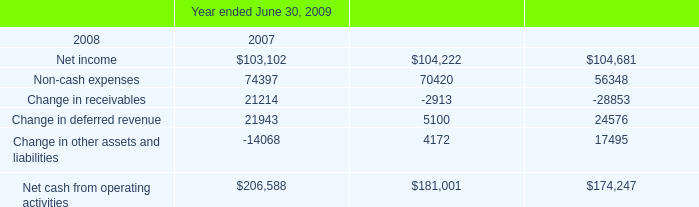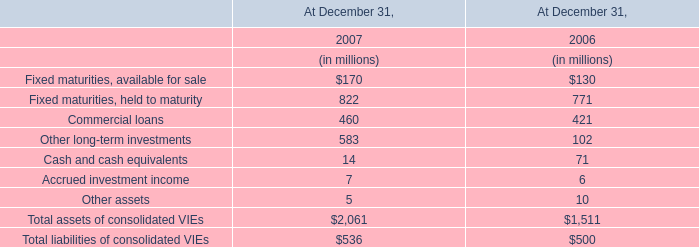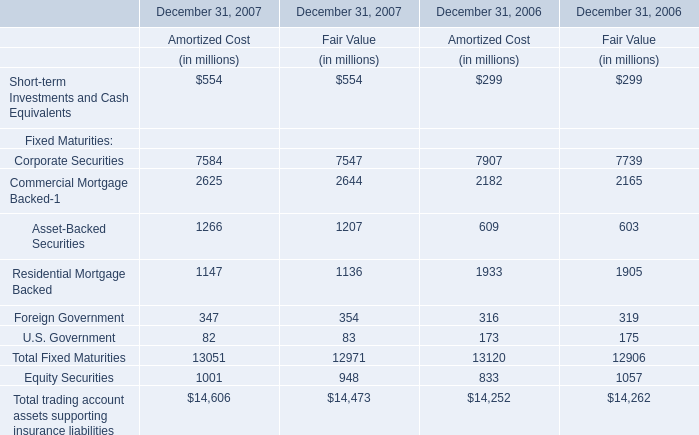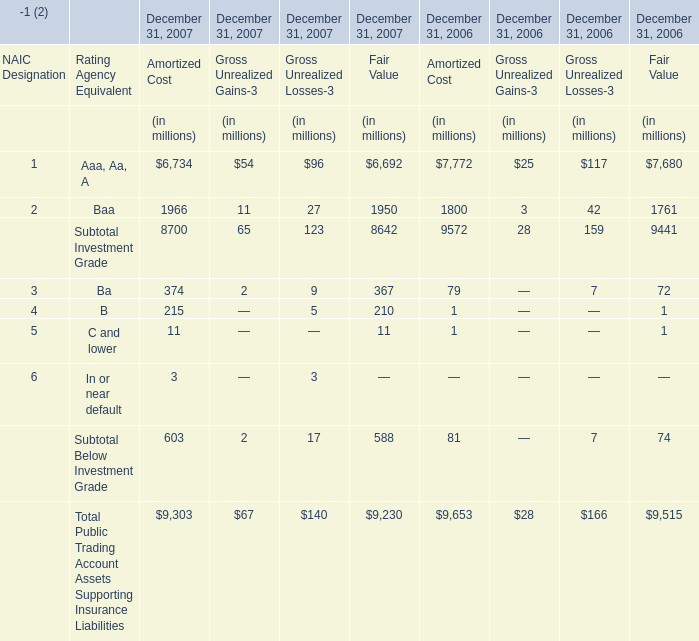Does the average value of Total Fixed Maturities in 2007 for fair value greater than that in 2006 for fair value ? 
Computations: ((12971 / 6) - (12906 / 6))
Answer: 10.83333. 